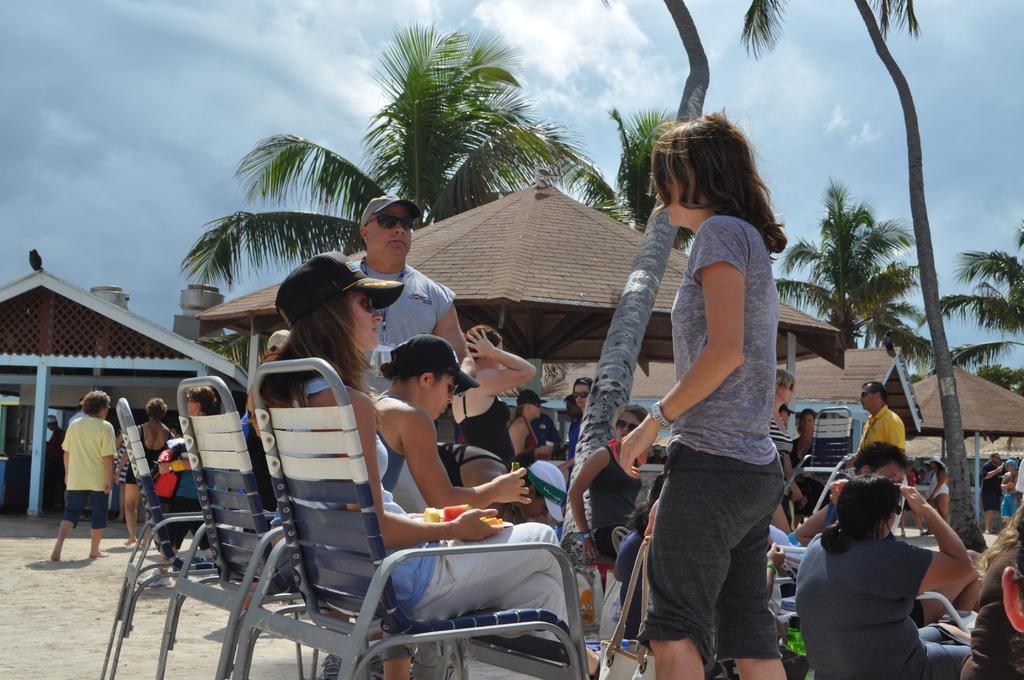Describe this image in one or two sentences. In this picture there are group of people sitting and there are group of people standing. At the back there are houses and trees. At the top there is sky and there are clouds. At the bottom there is sand. 